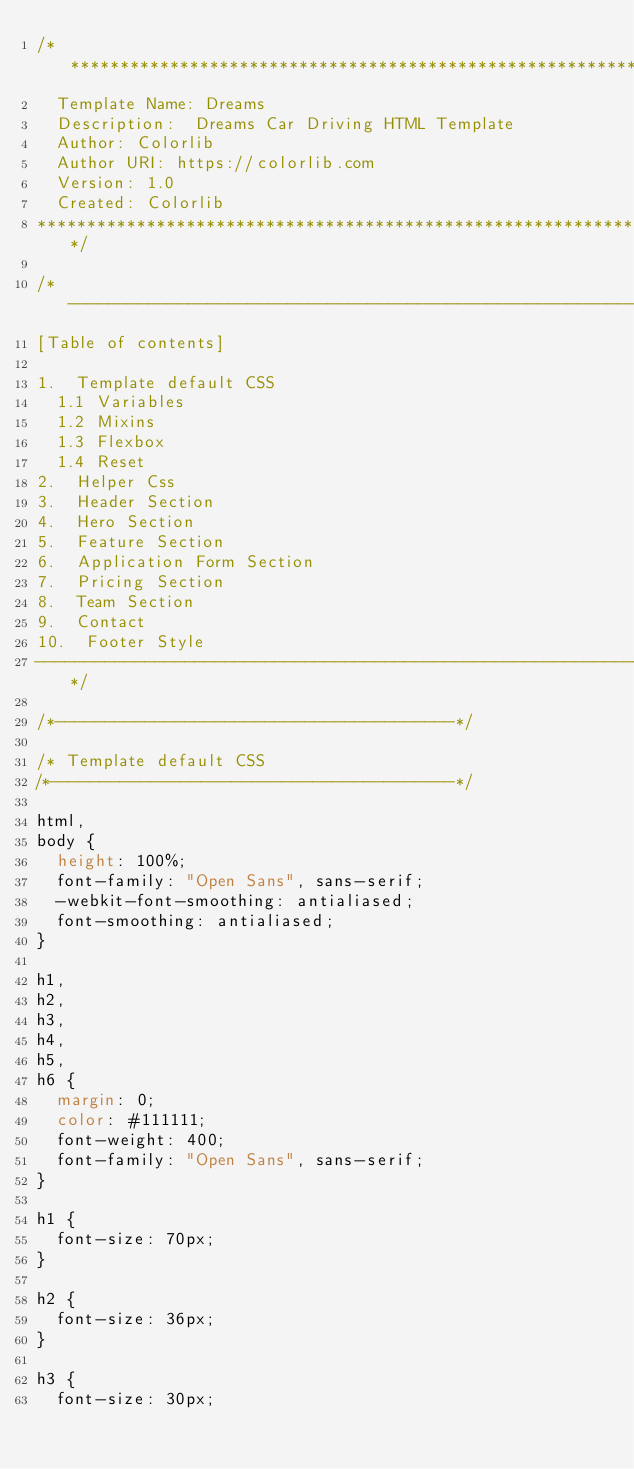Convert code to text. <code><loc_0><loc_0><loc_500><loc_500><_CSS_>/******************************************************************
  Template Name: Dreams
  Description:  Dreams Car Driving HTML Template
  Author: Colorlib
  Author URI: https://colorlib.com
  Version: 1.0
  Created: Colorlib
******************************************************************/

/*------------------------------------------------------------------
[Table of contents]

1.  Template default CSS
	1.1	Variables
	1.2	Mixins
	1.3	Flexbox
	1.4	Reset
2.  Helper Css
3.  Header Section
4.  Hero Section
5.  Feature Section
6.  Application Form Section
7.  Pricing Section
8.  Team Section
9.  Contact
10.  Footer Style
-------------------------------------------------------------------*/

/*----------------------------------------*/

/* Template default CSS
/*----------------------------------------*/

html,
body {
	height: 100%;
	font-family: "Open Sans", sans-serif;
	-webkit-font-smoothing: antialiased;
	font-smoothing: antialiased;
}

h1,
h2,
h3,
h4,
h5,
h6 {
	margin: 0;
	color: #111111;
	font-weight: 400;
	font-family: "Open Sans", sans-serif;
}

h1 {
	font-size: 70px;
}

h2 {
	font-size: 36px;
}

h3 {
	font-size: 30px;</code> 